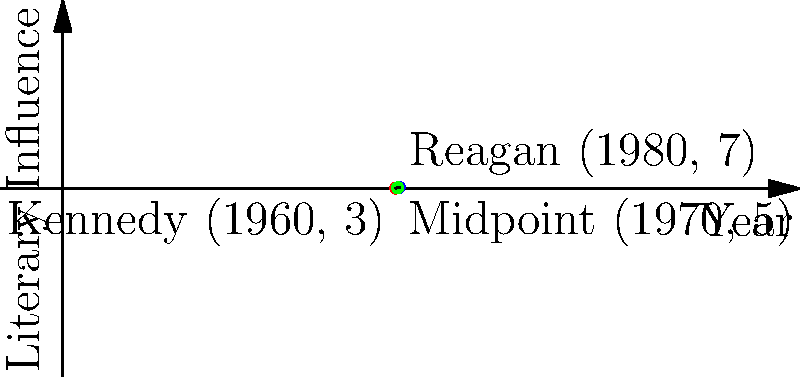On a coordinate plane representing presidential administrations and their influence on literary trends, the Kennedy administration is represented by the point (1960, 3), and the Reagan administration by (1980, 7). What are the coordinates of the midpoint between these two administrations, potentially representing a transitional period in American literature? To find the midpoint between two points, we use the midpoint formula:

$$ \text{Midpoint} = \left(\frac{x_1 + x_2}{2}, \frac{y_1 + y_2}{2}\right) $$

Where $(x_1, y_1)$ represents the first point and $(x_2, y_2)$ represents the second point.

For Kennedy administration: $(x_1, y_1) = (1960, 3)$
For Reagan administration: $(x_2, y_2) = (1980, 7)$

Applying the formula:

$x$-coordinate: $\frac{x_1 + x_2}{2} = \frac{1960 + 1980}{2} = \frac{3940}{2} = 1970$

$y$-coordinate: $\frac{y_1 + y_2}{2} = \frac{3 + 7}{2} = \frac{10}{2} = 5$

Therefore, the midpoint coordinates are (1970, 5).

This point represents the year 1970 with a literary influence value of 5, potentially indicating a transitional period between the Kennedy and Reagan administrations in terms of their impact on American literature.
Answer: (1970, 5) 